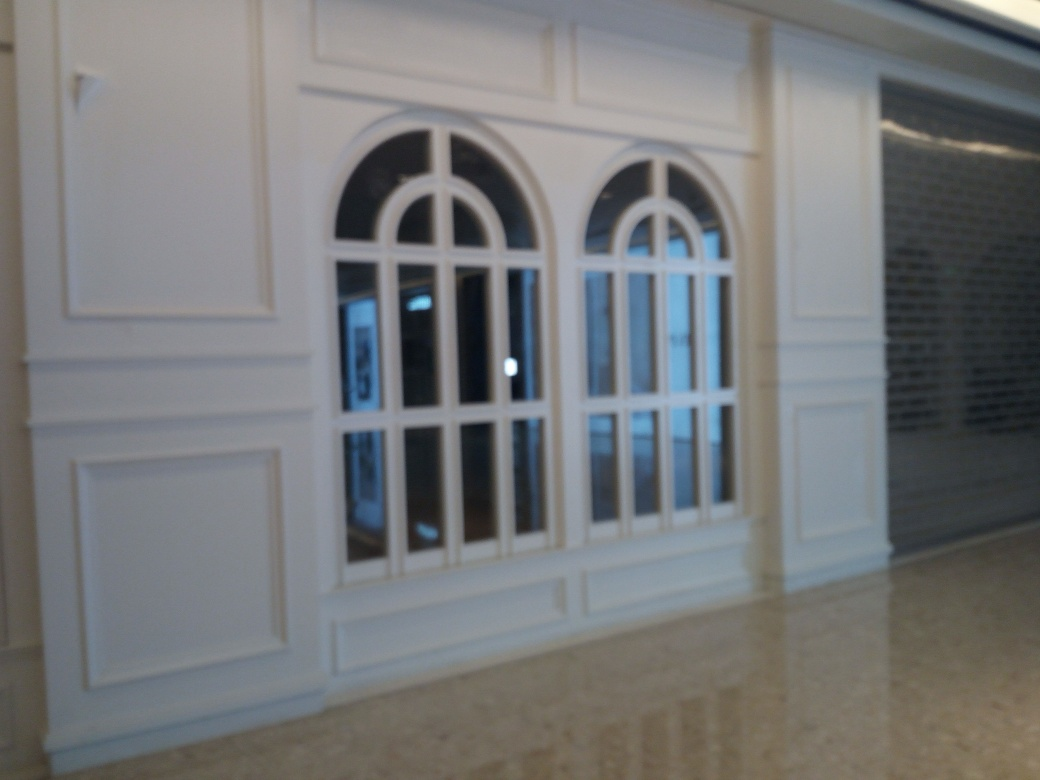Are there focusing issues? Indeed, the image appears to be slightly out of focus, particularly noticeable around the edges of the windows and the texture of the walls and floor. A crisper focus would reveal more details of the interior design, the materials used, and the reflections on the glossy floor. 